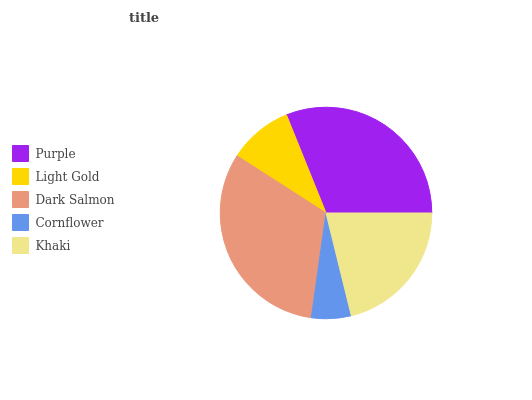Is Cornflower the minimum?
Answer yes or no. Yes. Is Dark Salmon the maximum?
Answer yes or no. Yes. Is Light Gold the minimum?
Answer yes or no. No. Is Light Gold the maximum?
Answer yes or no. No. Is Purple greater than Light Gold?
Answer yes or no. Yes. Is Light Gold less than Purple?
Answer yes or no. Yes. Is Light Gold greater than Purple?
Answer yes or no. No. Is Purple less than Light Gold?
Answer yes or no. No. Is Khaki the high median?
Answer yes or no. Yes. Is Khaki the low median?
Answer yes or no. Yes. Is Cornflower the high median?
Answer yes or no. No. Is Cornflower the low median?
Answer yes or no. No. 